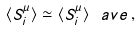Convert formula to latex. <formula><loc_0><loc_0><loc_500><loc_500>\langle S ^ { \mu } _ { i } \rangle \simeq \langle S ^ { \mu } _ { i } \rangle ^ { \ } a v e \, ,</formula> 